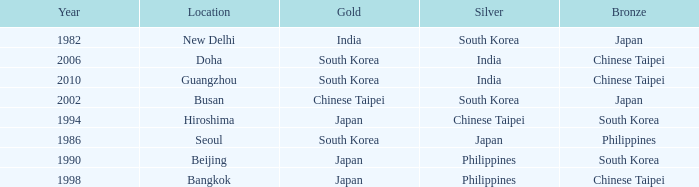Which Bronze has a Year smaller than 1994, and a Silver of south korea? Japan. 